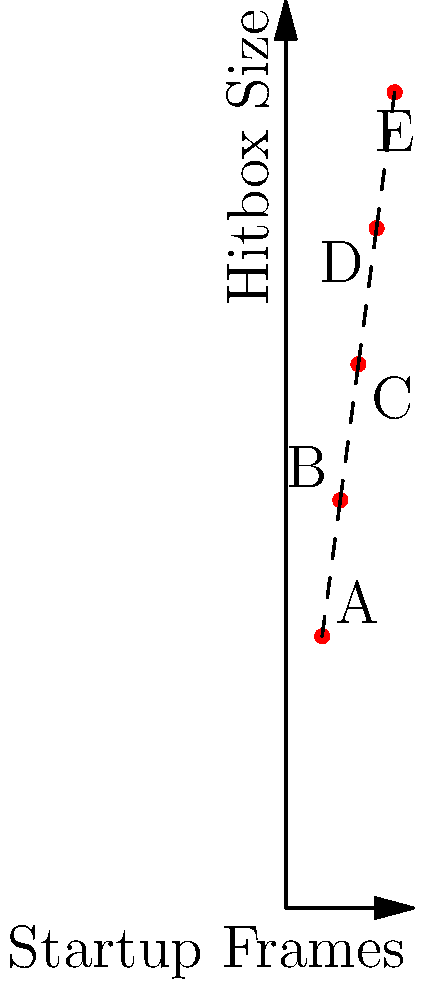Based on the graph showing the relationship between startup frames and hitbox sizes for five different fighting game moves (A, B, C, D, and E), which move would be considered the most optimal for a quick, high-priority attack in a neutral situation? To determine the most optimal move for a quick, high-priority attack in a neutral situation, we need to consider both the startup frames and hitbox size:

1. Analyze startup frames:
   - Move A: 4 frames
   - Move B: 6 frames
   - Move C: 8 frames
   - Move D: 10 frames
   - Move E: 12 frames

   Lower startup frames mean faster attacks.

2. Analyze hitbox sizes:
   - Move A: 30
   - Move B: 45
   - Move C: 60
   - Move D: 75
   - Move E: 90

   Larger hitbox sizes generally mean better range and priority.

3. Consider the trade-off:
   - We want a move that balances speed (low startup frames) and priority (large hitbox).
   - Move A is the fastest but has the smallest hitbox.
   - Move E has the largest hitbox but is the slowest.

4. Evaluate the options:
   - Move B offers a good balance between speed (6 frames) and hitbox size (45).
   - It's significantly faster than C, D, and E, while having a much larger hitbox than A.

5. Conclusion:
   Move B provides the best compromise between speed and priority, making it the most optimal choice for a quick, high-priority attack in a neutral situation.
Answer: Move B 